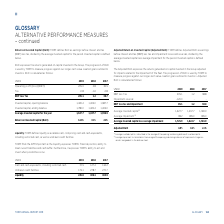According to Torm's financial document, How does TORM define RoIC? TORM defines RoIC as earnings before interest and tax (EBIT) less tax, divided by the average invested capital for the period. The document states: "Return on Invested Capital (RoIC): TORM defines RoIC as earnings before interest and tax (EBIT) less tax, divided by the average invested capital for ..." Also, What is the progression of RoIC used by TORM for? The progression of RoIC is used by TORM to measure progress against our longer-term value creation goals outlined to investors.. The document states: "eturns generated on capital invested in the Group. The progression of RoIC is used by TORM to measure progress against our longer-term value creation ..." Also, What are the components in the table which is used to directly derive the RoIC? The document shows two values: EBIT less Tax and Average invested capital for the year. From the document: "Average invested capital for the year 1,627.7 1,437.7 1,396.9 EBIT less Tax 205.1 1.2 38.7..." Additionally, In which year was the Invested capital, opening balance the largest? According to the financial document, 2019. The relevant text states: "USDm 2019 2018 2017..." Also, can you calculate: What was the change in the Average invested capital for the year in 2019 from 2018? Based on the calculation: 1,627.7-1,437.7, the result is 190 (in millions). This is based on the information: "Average invested capital for the year 1,627.7 1,437.7 1,396.9 Average invested capital for the year 1,627.7 1,437.7 1,396.9..." The key data points involved are: 1,437.7, 1,627.7. Also, can you calculate: What was the percentage change in the Average invested capital for the year in 2019 from 2018? To answer this question, I need to perform calculations using the financial data. The calculation is: (1,627.7-1,437.7)/1,437.7, which equals 13.22 (percentage). This is based on the information: "Average invested capital for the year 1,627.7 1,437.7 1,396.9 Average invested capital for the year 1,627.7 1,437.7 1,396.9..." The key data points involved are: 1,437.7, 1,627.7. 